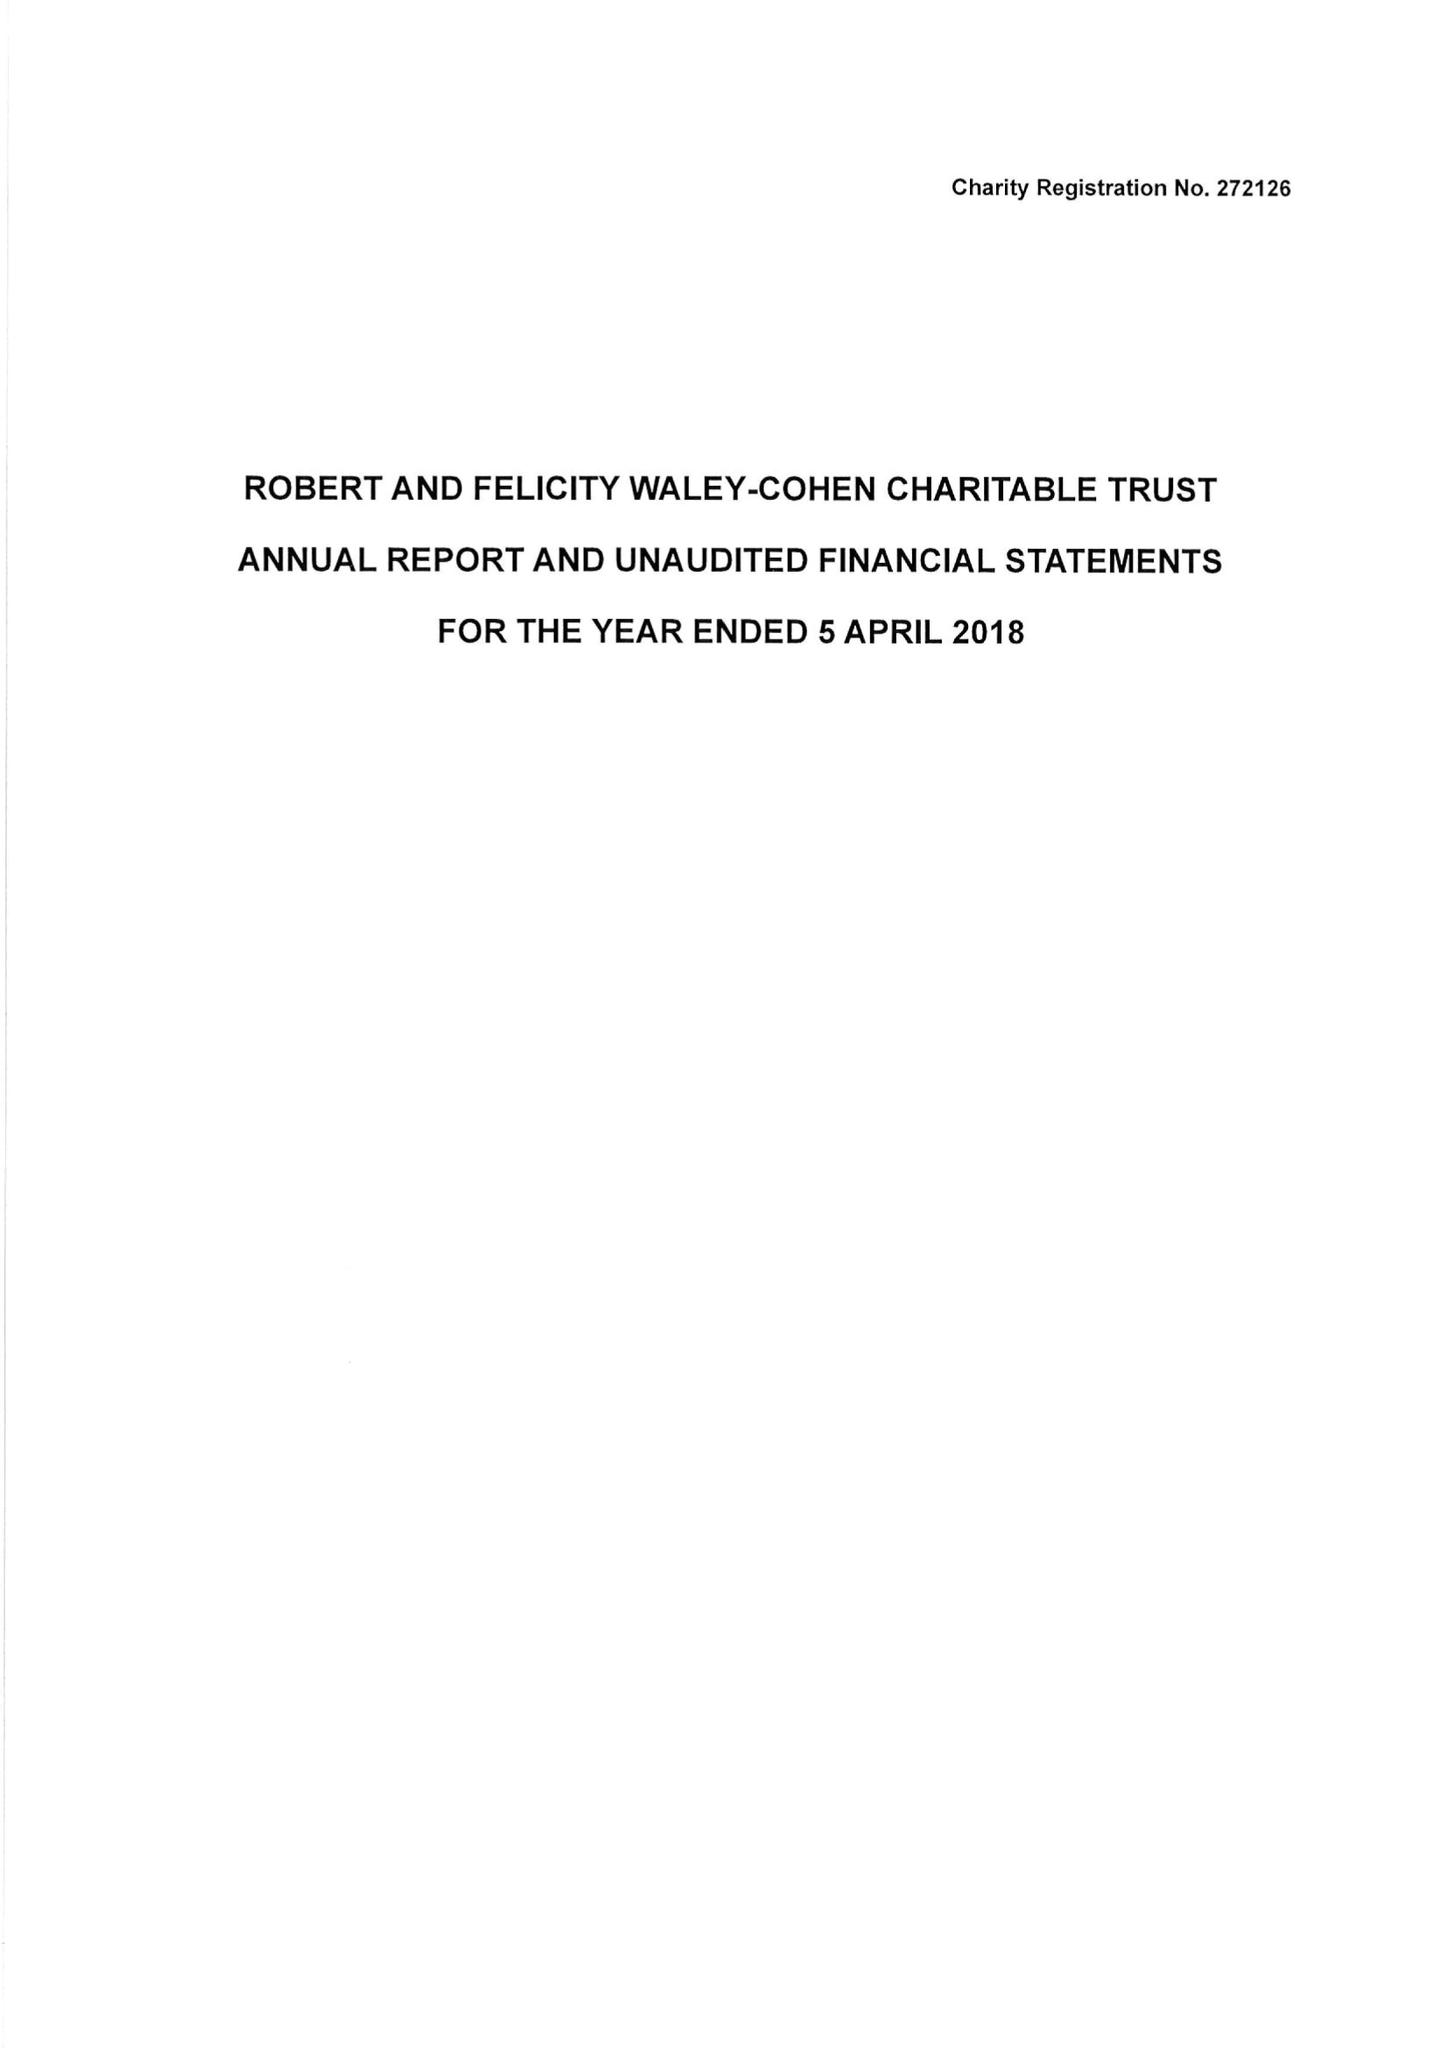What is the value for the charity_number?
Answer the question using a single word or phrase. 272126 